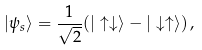<formula> <loc_0><loc_0><loc_500><loc_500>| \psi _ { s } \rangle = \frac { 1 } { \sqrt { 2 } } ( | \uparrow \downarrow \rangle - | \downarrow \uparrow \rangle ) \, ,</formula> 